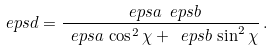Convert formula to latex. <formula><loc_0><loc_0><loc_500><loc_500>\ e p s d = \frac { \ e p s a \ e p s b } { \ e p s a \, \cos ^ { 2 } \chi + \ e p s b \, \sin ^ { 2 } \chi } \, .</formula> 